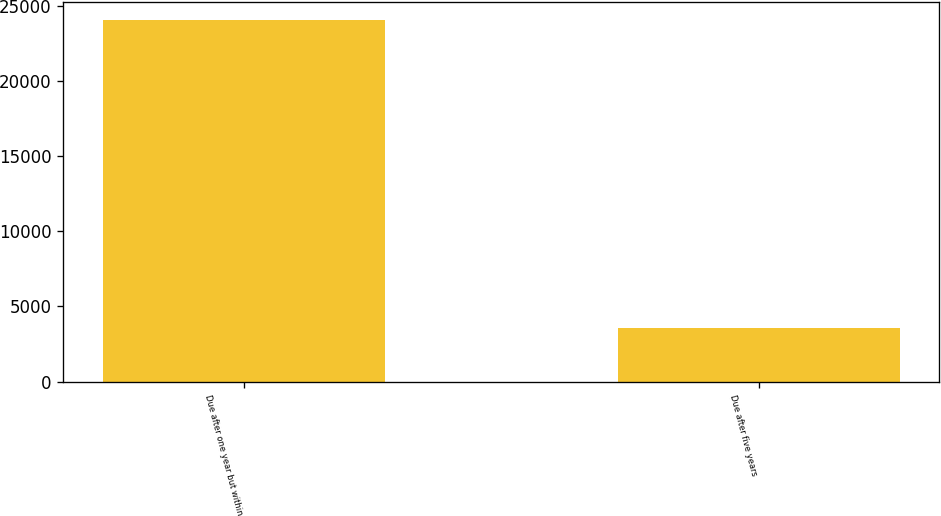Convert chart. <chart><loc_0><loc_0><loc_500><loc_500><bar_chart><fcel>Due after one year but within<fcel>Due after five years<nl><fcel>24036<fcel>3585<nl></chart> 